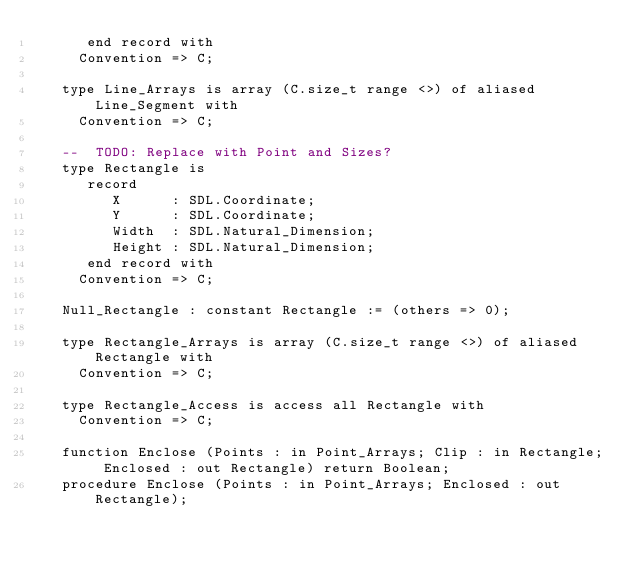<code> <loc_0><loc_0><loc_500><loc_500><_Ada_>      end record with
     Convention => C;

   type Line_Arrays is array (C.size_t range <>) of aliased Line_Segment with
     Convention => C;

   --  TODO: Replace with Point and Sizes?
   type Rectangle is
      record
         X      : SDL.Coordinate;
         Y      : SDL.Coordinate;
         Width  : SDL.Natural_Dimension;
         Height : SDL.Natural_Dimension;
      end record with
     Convention => C;

   Null_Rectangle : constant Rectangle := (others => 0);

   type Rectangle_Arrays is array (C.size_t range <>) of aliased Rectangle with
     Convention => C;

   type Rectangle_Access is access all Rectangle with
     Convention => C;

   function Enclose (Points : in Point_Arrays; Clip : in Rectangle; Enclosed : out Rectangle) return Boolean;
   procedure Enclose (Points : in Point_Arrays; Enclosed : out Rectangle);
</code> 